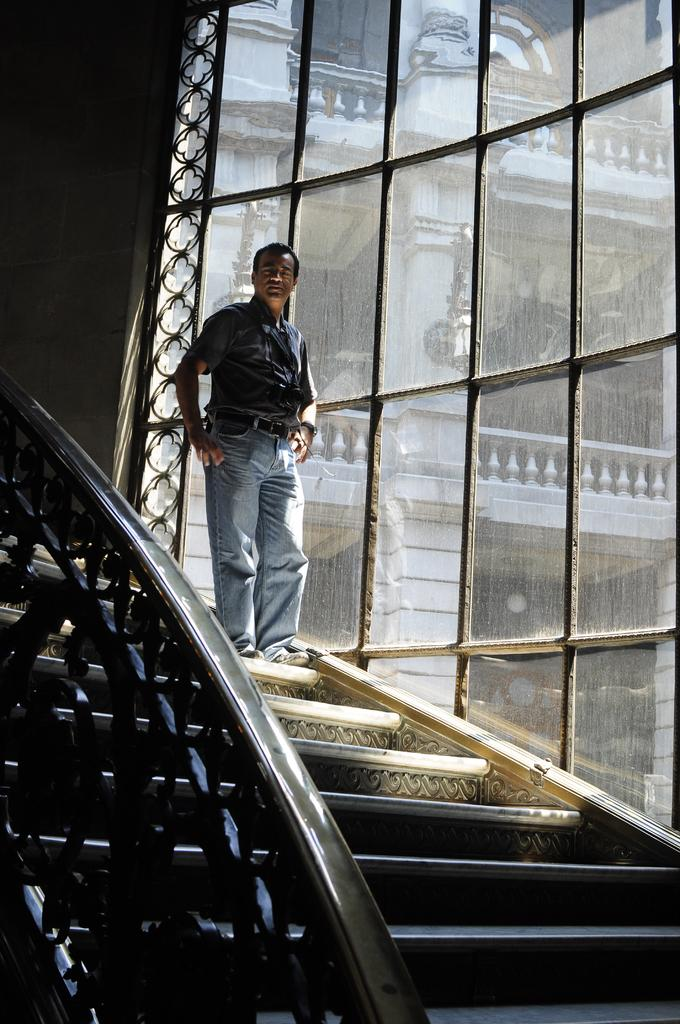Who is present in the image? There is a man in the image. What is the man wearing? The man is wearing a shirt, jeans, and shoes. Where is the man located in the image? The man is standing on stairs. What can be seen on the right side of the image? There is a glass window on the right side of the image. What is visible through the window? A building is visible through the window. What type of dinner is the man preparing in the image? There is no indication in the image that the man is preparing dinner, as he is simply standing on stairs with no visible cooking or food preparation activities. 